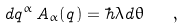<formula> <loc_0><loc_0><loc_500><loc_500>d q ^ { \alpha } \, A _ { \alpha } ( q ) = \hbar { \lambda } d \theta \quad ,</formula> 